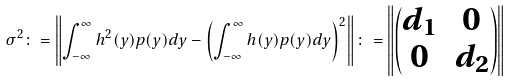Convert formula to latex. <formula><loc_0><loc_0><loc_500><loc_500>\sigma ^ { 2 } \colon = \left \| \int _ { - \infty } ^ { \infty } h ^ { 2 } ( y ) p ( y ) d y - \left ( \int _ { - \infty } ^ { \infty } h ( y ) p ( y ) d y \right ) ^ { 2 } \right \| \colon = \left \| \begin{pmatrix} d _ { 1 } & 0 \\ 0 & d _ { 2 } \end{pmatrix} \right \|</formula> 